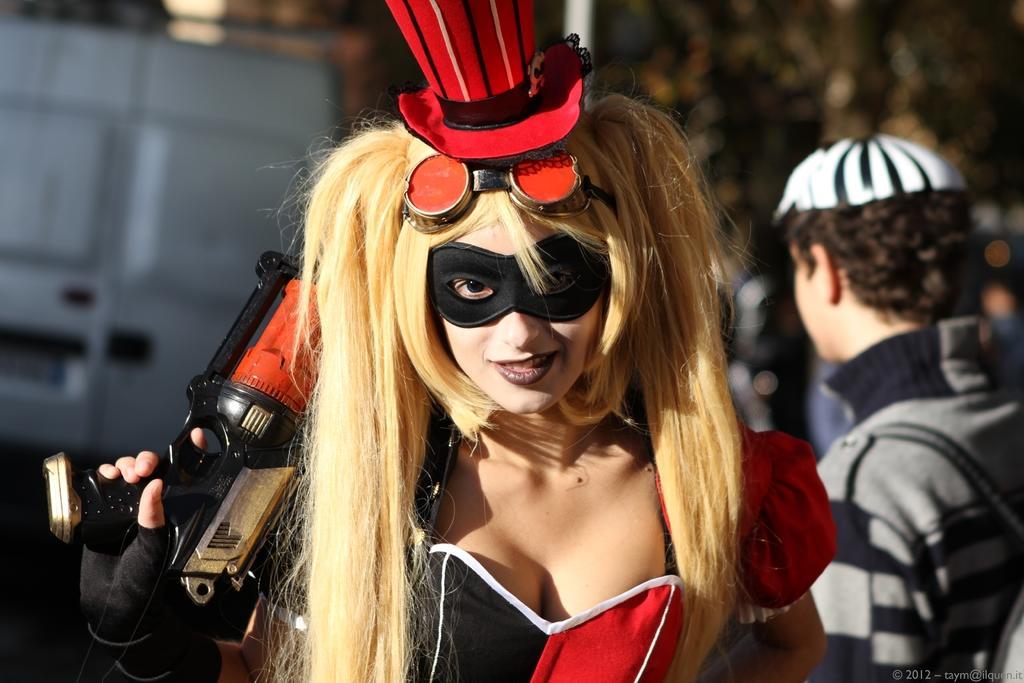Could you give a brief overview of what you see in this image? In the foreground, I can see a woman in costume and is holding an object in hand. In the background, I can see a group of people and vehicles. This image might be taken on the road. 